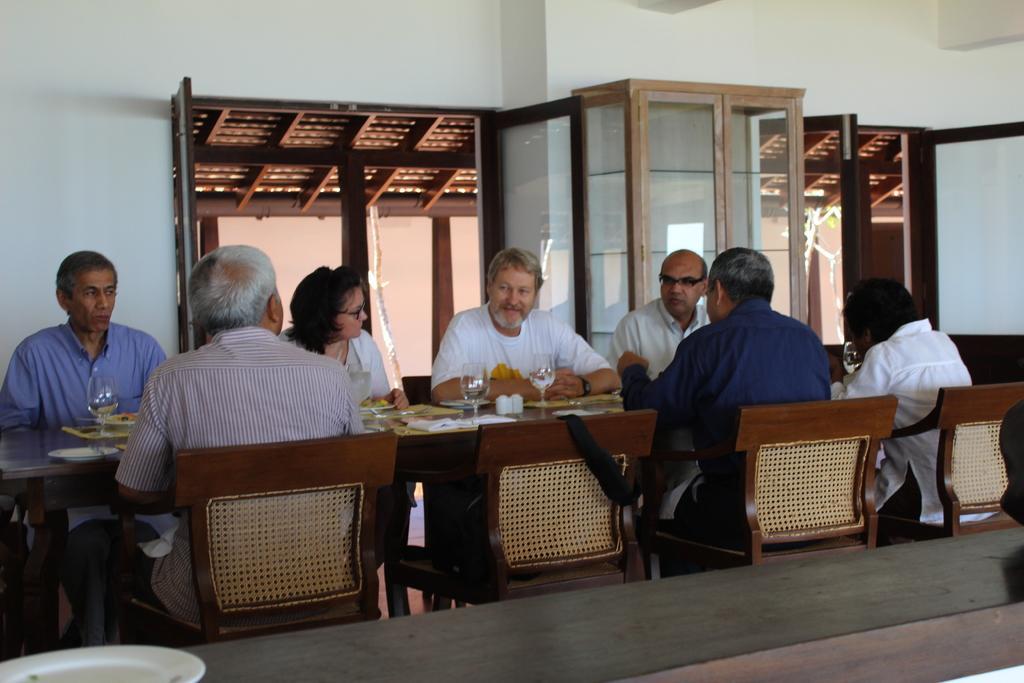Please provide a concise description of this image. In the image there are few people sitting on chairs , in front of them there is dining table. On the table there are glasses, napkins. In the background there is or, there are glass window. 